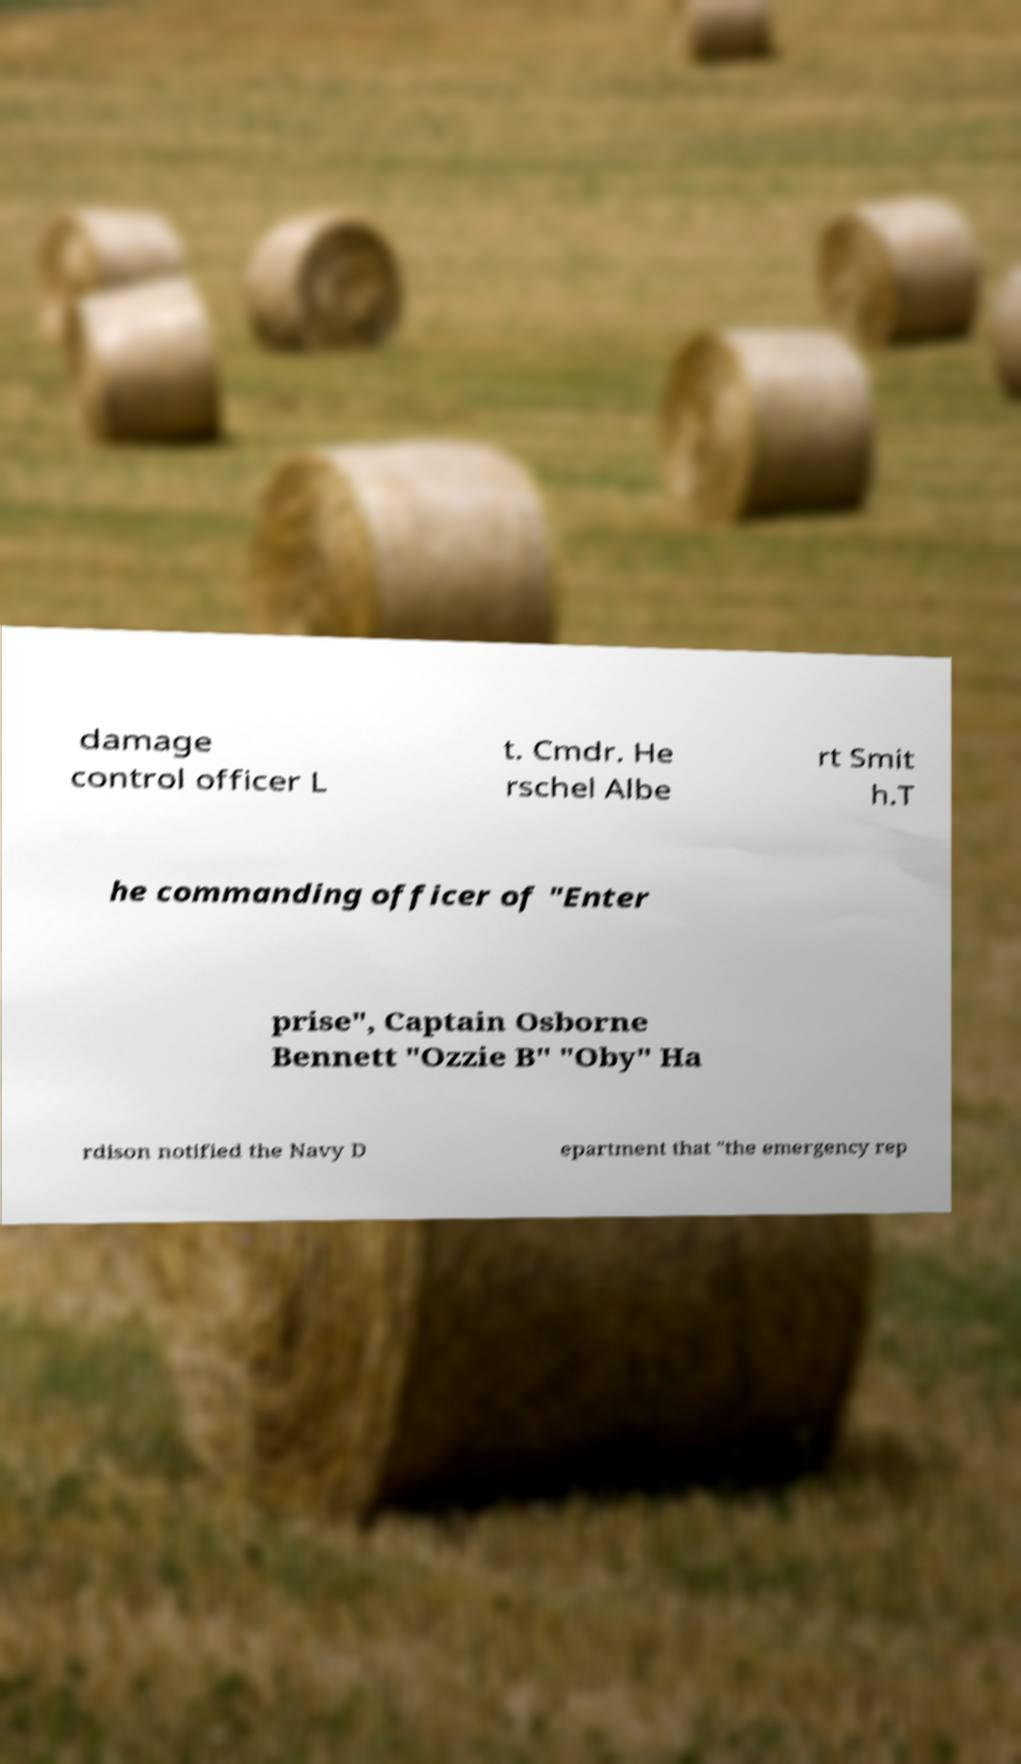For documentation purposes, I need the text within this image transcribed. Could you provide that? damage control officer L t. Cmdr. He rschel Albe rt Smit h.T he commanding officer of "Enter prise", Captain Osborne Bennett "Ozzie B" "Oby" Ha rdison notified the Navy D epartment that "the emergency rep 